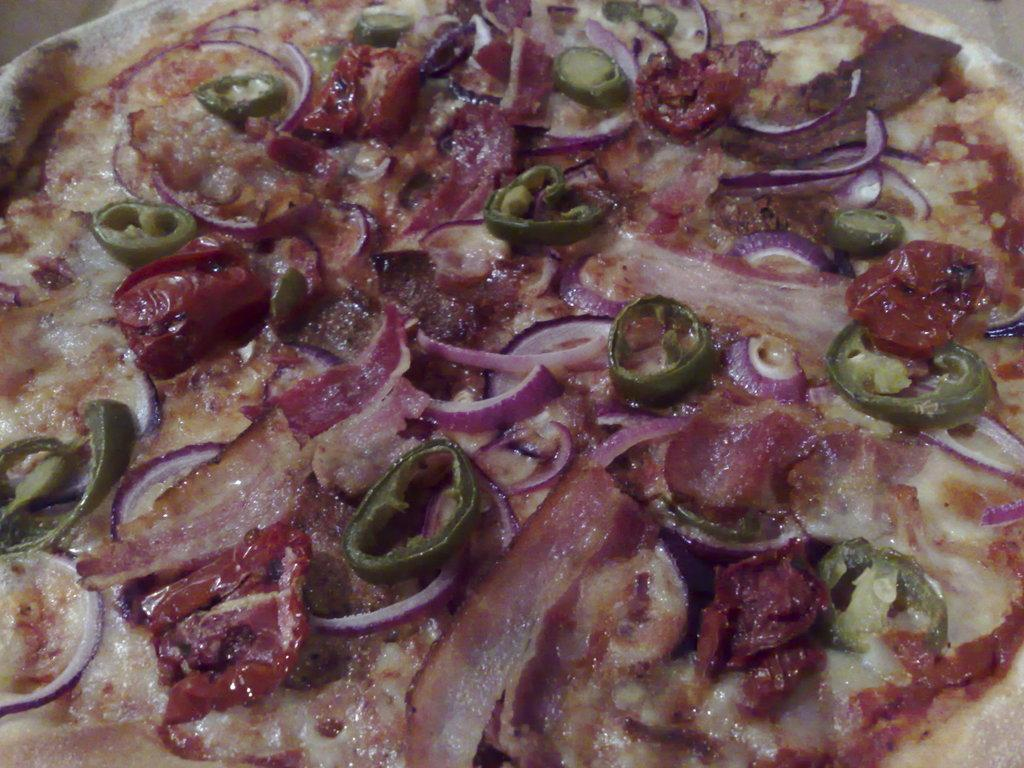What type of food item is visible in the image? There is a food item in the image. What specific ingredients can be seen on the food item? There are onion slices and green chili slices on the food item. How many mice are hiding under the green chili slices in the image? There are no mice present in the image; it only features a food item with onion and green chili slices. 